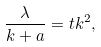<formula> <loc_0><loc_0><loc_500><loc_500>\frac { \lambda } { k + a } = t k ^ { 2 } ,</formula> 